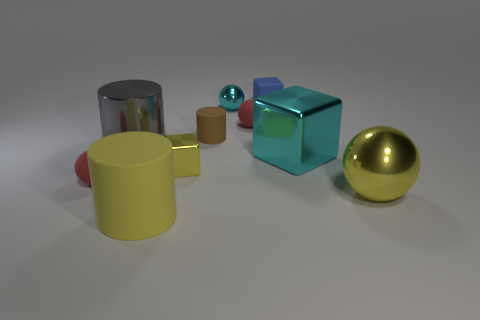Are there the same number of big cyan objects to the left of the small yellow metallic object and tiny cyan spheres?
Provide a succinct answer. No. Do the gray object and the object that is to the left of the big gray cylinder have the same size?
Your answer should be compact. No. There is a large object that is left of the large rubber cylinder; what is its shape?
Your answer should be very brief. Cylinder. Are there any other things that are the same shape as the brown rubber object?
Give a very brief answer. Yes. Is there a yellow rubber cylinder?
Offer a terse response. Yes. Is the size of the matte sphere on the right side of the big gray metallic cylinder the same as the sphere left of the cyan metallic sphere?
Provide a short and direct response. Yes. What is the big thing that is both on the left side of the brown rubber object and in front of the small yellow thing made of?
Give a very brief answer. Rubber. How many tiny matte objects are behind the tiny yellow block?
Make the answer very short. 3. Is there anything else that has the same size as the brown rubber cylinder?
Provide a short and direct response. Yes. The cylinder that is made of the same material as the large yellow ball is what color?
Provide a short and direct response. Gray. 